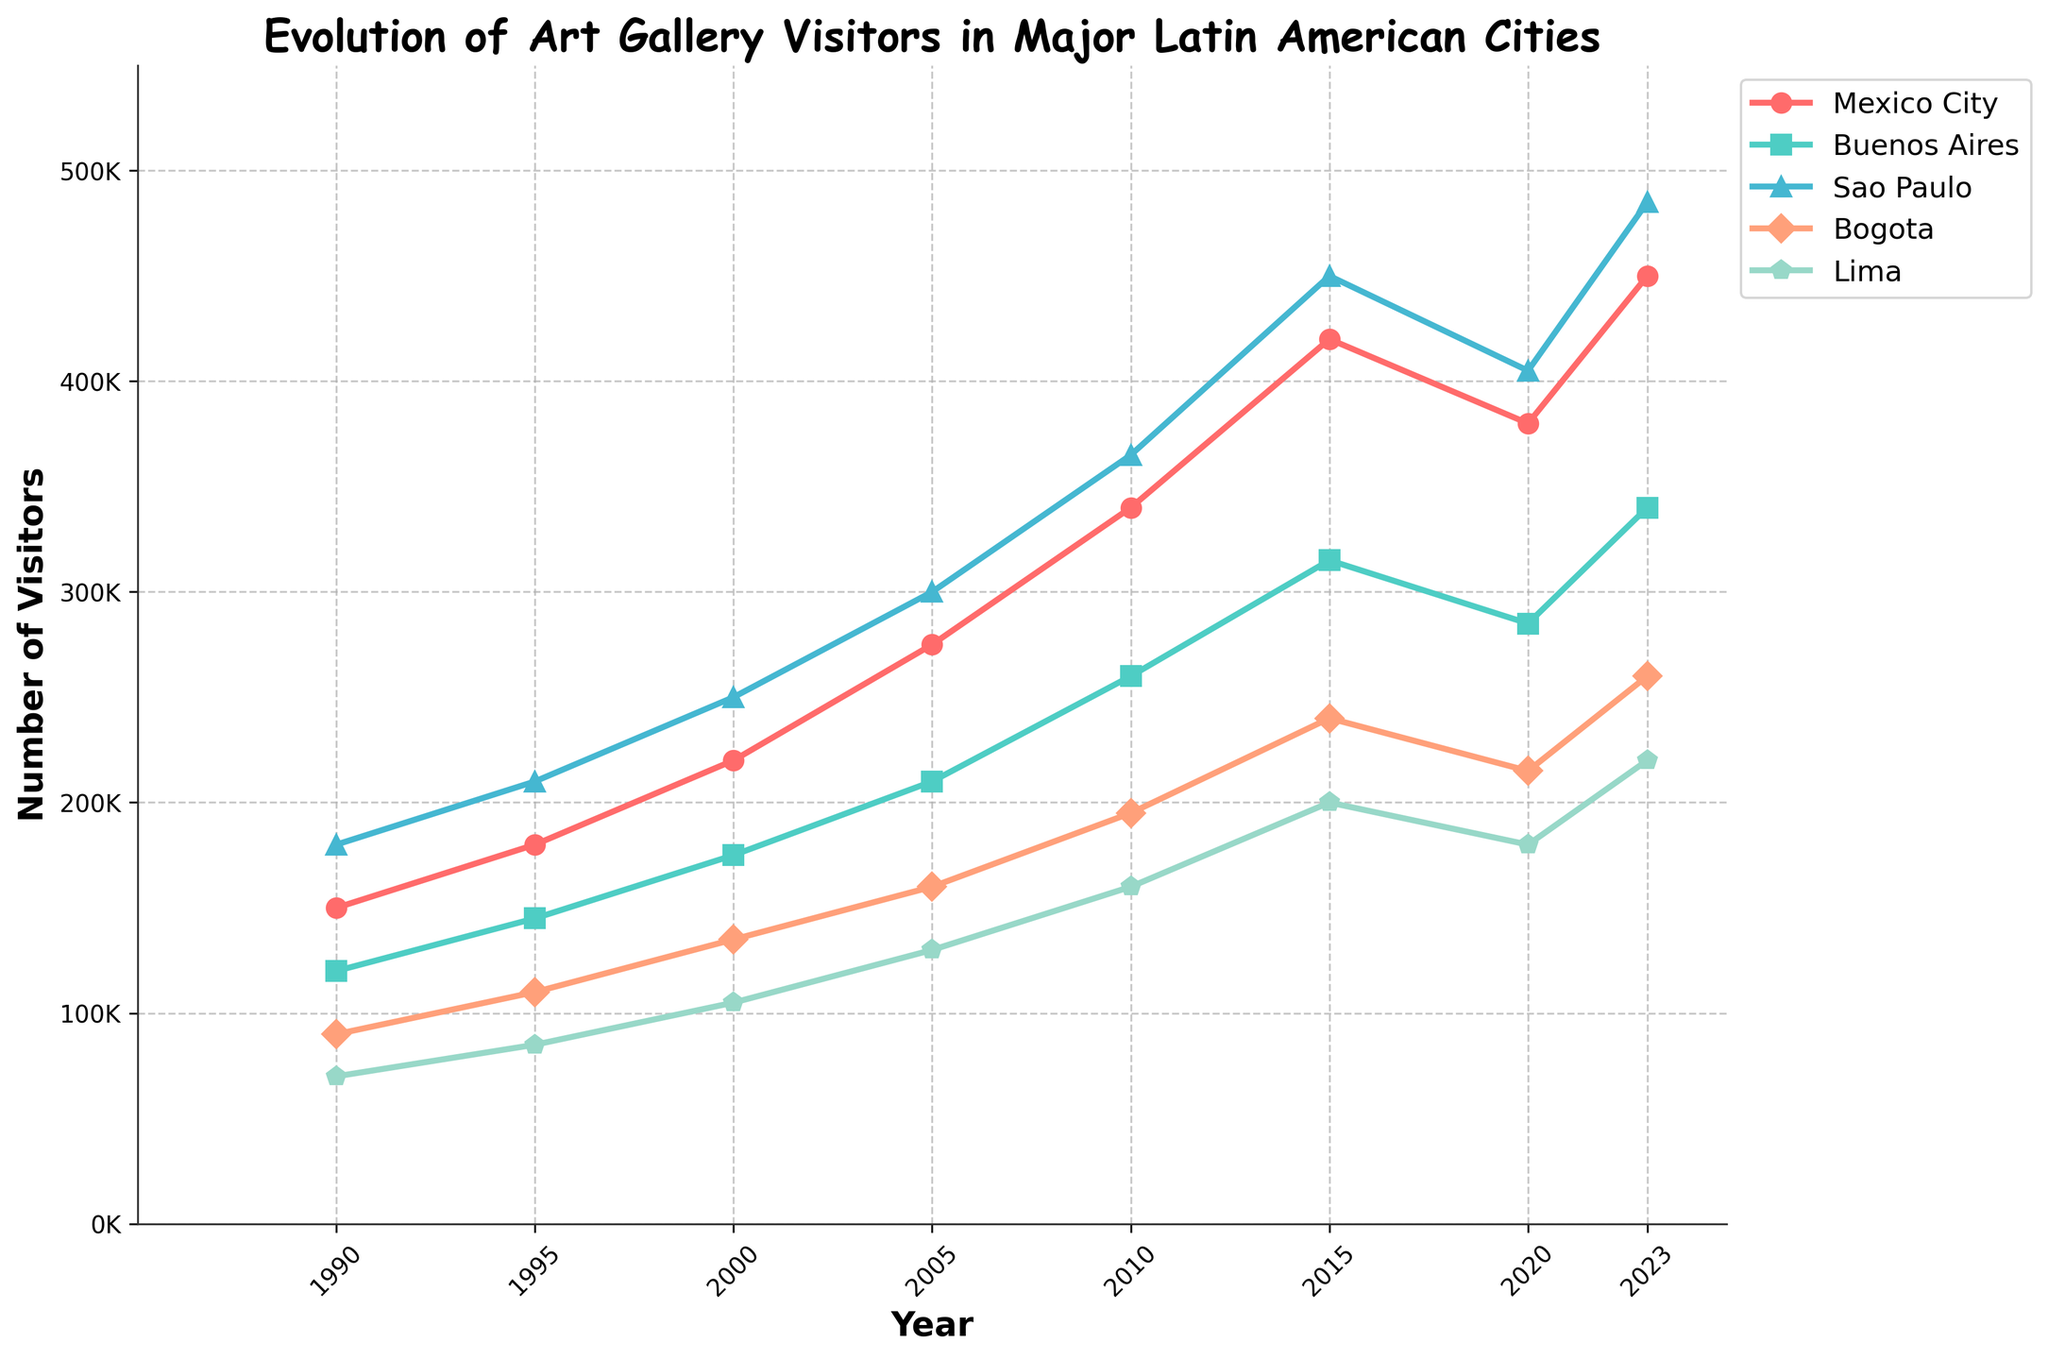Which city had the highest number of art gallery visitors in 2023? The blue line with triangle markers represents Sao Paulo, which reaches the highest point on the figure in 2023.
Answer: Sao Paulo Which city showed the largest increase in art gallery visitors from 1990 to 2023? To find this, calculate the difference in visitors for each city from 1990 to 2023. Sao Paulo increased from 180,000 to 485,000, a difference of 305,000, which is larger than the increases for the other cities.
Answer: Sao Paulo In which year did Mexico City first surpass 300,000 visitors? Follow the red line with circle markers and note the year it crosses the 300,000 visitor mark. This occurs in 2005.
Answer: 2005 Between which consecutive years did Buenos Aires experience the largest growth in art gallery visitors? Observe the green line with square markers for the steepest ascent. The steepest increase happens between 2010 and 2015.
Answer: 2010 to 2015 Which city had a decline in visitors between 2015 and 2020? By inspecting each line, Mexico City (represented by the red line with circle markers) shows a decline from 420,000 in 2015 to 380,000 in 2020.
Answer: Mexico City What was the average number of visitors in 2023 for Lima and Bogota? Sum the visitors for Lima (220,000) and Bogota (260,000) in 2023, then divide by 2. The calculation is (220,000 + 260,000) / 2 = 240,000.
Answer: 240,000 How many years did it take for Buenos Aires to double its 1990 visitor numbers? Buenos Aires had 120,000 visitors in 1990 and the number doubles to 240,000. This milestone is reached in 2015. Subtract 1990 from 2015 to get 25 years.
Answer: 25 years Which year saw the highest total increase in number of visitors across all cities from the previous recorded year? Calculate the increase in visitors for each city between consecutive years. The year 2000 shows the largest total increase (220,000 - 180,000 + 175,000 - 145,000 + 250,000 - 210,000 + 135,000 - 110,000 + 105,000 - 85,000 = 395,000).
Answer: 2000 